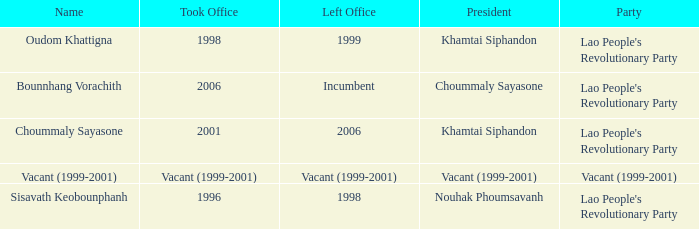What is Left Office, when Took Office is 1998? 1999.0. Could you parse the entire table? {'header': ['Name', 'Took Office', 'Left Office', 'President', 'Party'], 'rows': [['Oudom Khattigna', '1998', '1999', 'Khamtai Siphandon', "Lao People's Revolutionary Party"], ['Bounnhang Vorachith', '2006', 'Incumbent', 'Choummaly Sayasone', "Lao People's Revolutionary Party"], ['Choummaly Sayasone', '2001', '2006', 'Khamtai Siphandon', "Lao People's Revolutionary Party"], ['Vacant (1999-2001)', 'Vacant (1999-2001)', 'Vacant (1999-2001)', 'Vacant (1999-2001)', 'Vacant (1999-2001)'], ['Sisavath Keobounphanh', '1996', '1998', 'Nouhak Phoumsavanh', "Lao People's Revolutionary Party"]]} 